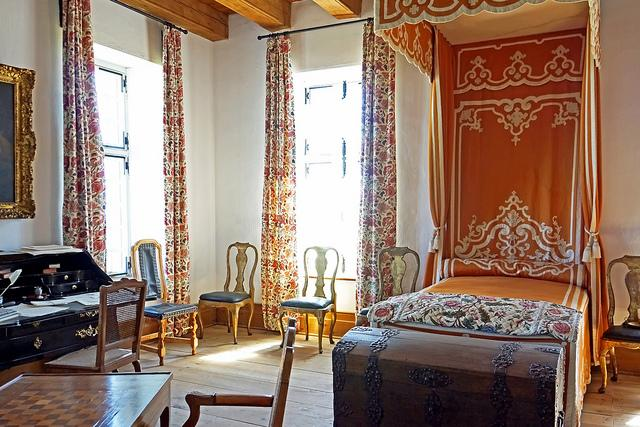What is the brown table at the left bottom corner for?

Choices:
A) preparing food
B) reading desk
C) coffee table
D) playing chess playing chess 